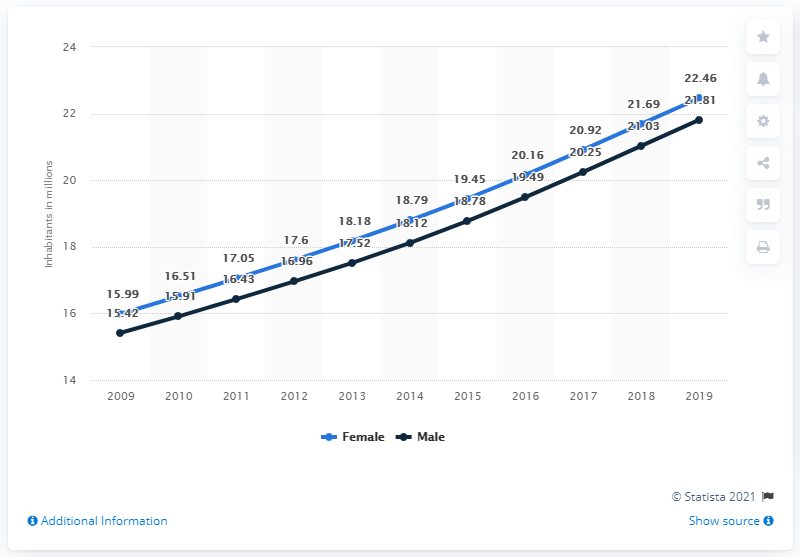Outline some significant characteristics in this image. As of 2019, the female population of Uganda was approximately 22.46 million. According to data from 2019, the male population of Uganda was approximately 21.81 million. 